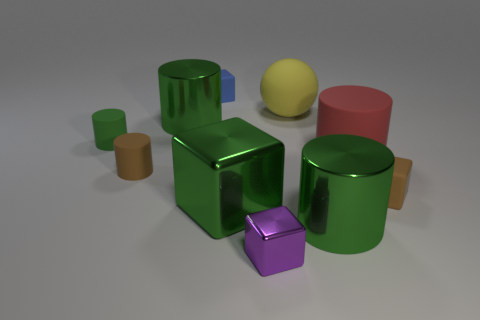Subtract all blue blocks. How many green cylinders are left? 3 Subtract all red rubber cylinders. How many cylinders are left? 4 Subtract all red cylinders. How many cylinders are left? 4 Subtract all red cylinders. Subtract all yellow spheres. How many cylinders are left? 4 Subtract all cubes. How many objects are left? 6 Subtract all shiny balls. Subtract all big yellow matte things. How many objects are left? 9 Add 3 big green cubes. How many big green cubes are left? 4 Add 3 small metal cylinders. How many small metal cylinders exist? 3 Subtract 0 cyan cylinders. How many objects are left? 10 